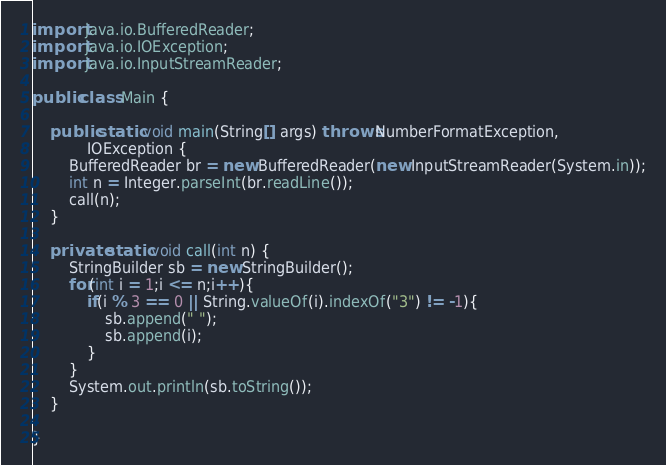<code> <loc_0><loc_0><loc_500><loc_500><_Java_>import java.io.BufferedReader;
import java.io.IOException;
import java.io.InputStreamReader;

public class Main {

	public static void main(String[] args) throws NumberFormatException,
			IOException {
		BufferedReader br = new BufferedReader(new InputStreamReader(System.in));
		int n = Integer.parseInt(br.readLine());
		call(n);
	}

	private static void call(int n) {
		StringBuilder sb = new StringBuilder();
		for(int i = 1;i <= n;i++){
			if(i % 3 == 0 || String.valueOf(i).indexOf("3") != -1){
				sb.append(" ");
				sb.append(i);
			}
		}
		System.out.println(sb.toString());
	}

}</code> 